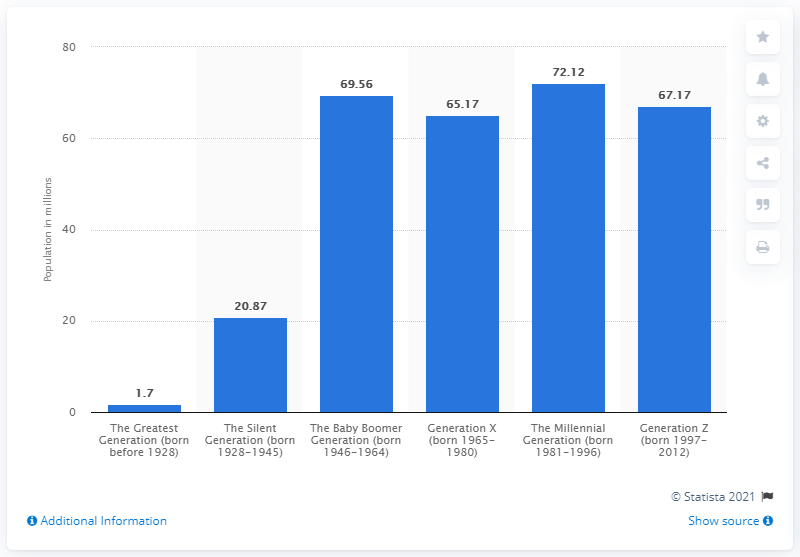Specify some key components in this picture. The Millennial Generation, born between 1981 and 1996, has the highest population among the generations. The sum of the two smallest values is 22.57. In 2019, the estimated population of Millennials was 72.12 million. 